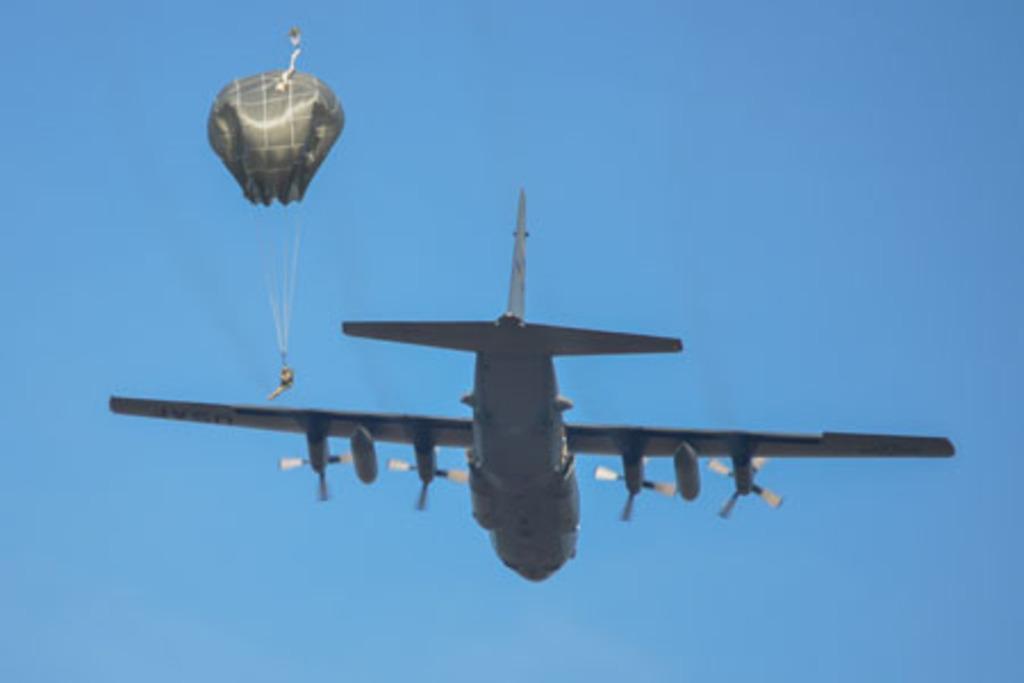Could you give a brief overview of what you see in this image? In this picture there is a plane flying in the air and there is a person holding a parachute beside it. 